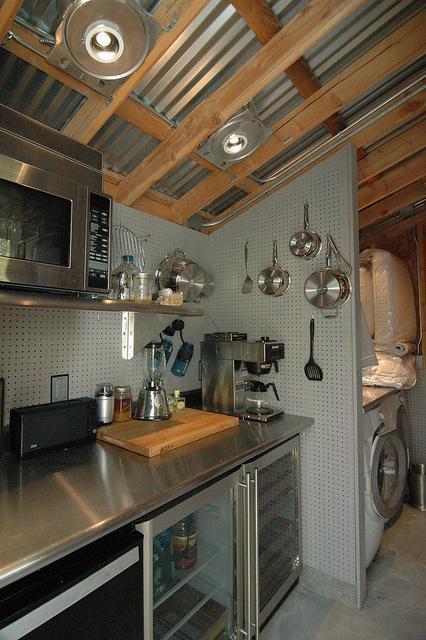How many elephants are there?
Give a very brief answer. 0. 